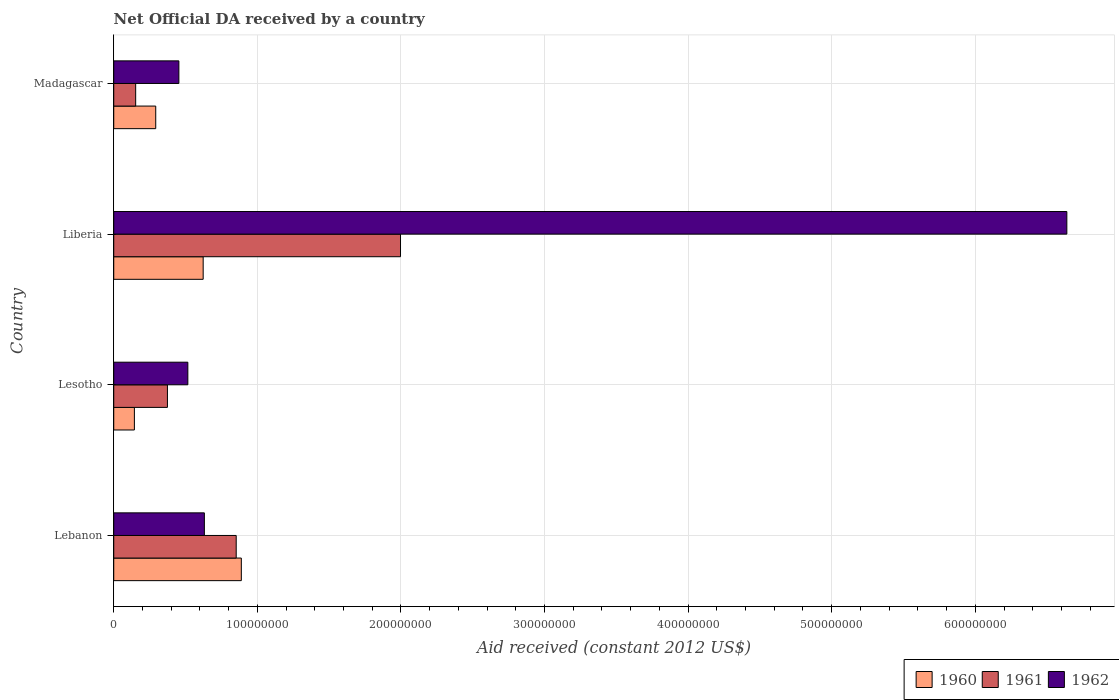How many different coloured bars are there?
Your answer should be very brief. 3. How many groups of bars are there?
Offer a terse response. 4. Are the number of bars per tick equal to the number of legend labels?
Your answer should be very brief. Yes. What is the label of the 3rd group of bars from the top?
Provide a short and direct response. Lesotho. What is the net official development assistance aid received in 1960 in Lesotho?
Your answer should be compact. 1.44e+07. Across all countries, what is the maximum net official development assistance aid received in 1962?
Make the answer very short. 6.64e+08. Across all countries, what is the minimum net official development assistance aid received in 1961?
Your answer should be compact. 1.53e+07. In which country was the net official development assistance aid received in 1960 maximum?
Your response must be concise. Lebanon. In which country was the net official development assistance aid received in 1960 minimum?
Keep it short and to the point. Lesotho. What is the total net official development assistance aid received in 1960 in the graph?
Make the answer very short. 1.95e+08. What is the difference between the net official development assistance aid received in 1960 in Lebanon and that in Lesotho?
Make the answer very short. 7.45e+07. What is the difference between the net official development assistance aid received in 1962 in Lesotho and the net official development assistance aid received in 1960 in Lebanon?
Provide a short and direct response. -3.72e+07. What is the average net official development assistance aid received in 1960 per country?
Your answer should be compact. 4.87e+07. What is the difference between the net official development assistance aid received in 1961 and net official development assistance aid received in 1960 in Lesotho?
Offer a terse response. 2.30e+07. In how many countries, is the net official development assistance aid received in 1962 greater than 460000000 US$?
Make the answer very short. 1. What is the ratio of the net official development assistance aid received in 1960 in Liberia to that in Madagascar?
Make the answer very short. 2.13. Is the difference between the net official development assistance aid received in 1961 in Lebanon and Lesotho greater than the difference between the net official development assistance aid received in 1960 in Lebanon and Lesotho?
Provide a succinct answer. No. What is the difference between the highest and the second highest net official development assistance aid received in 1960?
Offer a very short reply. 2.66e+07. What is the difference between the highest and the lowest net official development assistance aid received in 1960?
Your answer should be very brief. 7.45e+07. In how many countries, is the net official development assistance aid received in 1961 greater than the average net official development assistance aid received in 1961 taken over all countries?
Keep it short and to the point. 2. What does the 3rd bar from the bottom in Lesotho represents?
Keep it short and to the point. 1962. Is it the case that in every country, the sum of the net official development assistance aid received in 1962 and net official development assistance aid received in 1961 is greater than the net official development assistance aid received in 1960?
Your answer should be compact. Yes. Are all the bars in the graph horizontal?
Provide a succinct answer. Yes. How many countries are there in the graph?
Ensure brevity in your answer.  4. Are the values on the major ticks of X-axis written in scientific E-notation?
Your answer should be very brief. No. What is the title of the graph?
Your response must be concise. Net Official DA received by a country. What is the label or title of the X-axis?
Offer a terse response. Aid received (constant 2012 US$). What is the Aid received (constant 2012 US$) of 1960 in Lebanon?
Your answer should be compact. 8.88e+07. What is the Aid received (constant 2012 US$) of 1961 in Lebanon?
Your answer should be very brief. 8.53e+07. What is the Aid received (constant 2012 US$) in 1962 in Lebanon?
Ensure brevity in your answer.  6.31e+07. What is the Aid received (constant 2012 US$) in 1960 in Lesotho?
Your answer should be compact. 1.44e+07. What is the Aid received (constant 2012 US$) of 1961 in Lesotho?
Ensure brevity in your answer.  3.74e+07. What is the Aid received (constant 2012 US$) in 1962 in Lesotho?
Your answer should be very brief. 5.16e+07. What is the Aid received (constant 2012 US$) of 1960 in Liberia?
Your response must be concise. 6.23e+07. What is the Aid received (constant 2012 US$) of 1961 in Liberia?
Provide a short and direct response. 2.00e+08. What is the Aid received (constant 2012 US$) in 1962 in Liberia?
Make the answer very short. 6.64e+08. What is the Aid received (constant 2012 US$) of 1960 in Madagascar?
Your answer should be very brief. 2.92e+07. What is the Aid received (constant 2012 US$) of 1961 in Madagascar?
Ensure brevity in your answer.  1.53e+07. What is the Aid received (constant 2012 US$) of 1962 in Madagascar?
Make the answer very short. 4.54e+07. Across all countries, what is the maximum Aid received (constant 2012 US$) of 1960?
Provide a short and direct response. 8.88e+07. Across all countries, what is the maximum Aid received (constant 2012 US$) in 1961?
Offer a very short reply. 2.00e+08. Across all countries, what is the maximum Aid received (constant 2012 US$) of 1962?
Offer a very short reply. 6.64e+08. Across all countries, what is the minimum Aid received (constant 2012 US$) in 1960?
Provide a short and direct response. 1.44e+07. Across all countries, what is the minimum Aid received (constant 2012 US$) of 1961?
Provide a succinct answer. 1.53e+07. Across all countries, what is the minimum Aid received (constant 2012 US$) in 1962?
Your response must be concise. 4.54e+07. What is the total Aid received (constant 2012 US$) in 1960 in the graph?
Keep it short and to the point. 1.95e+08. What is the total Aid received (constant 2012 US$) in 1961 in the graph?
Keep it short and to the point. 3.38e+08. What is the total Aid received (constant 2012 US$) in 1962 in the graph?
Ensure brevity in your answer.  8.24e+08. What is the difference between the Aid received (constant 2012 US$) in 1960 in Lebanon and that in Lesotho?
Give a very brief answer. 7.45e+07. What is the difference between the Aid received (constant 2012 US$) of 1961 in Lebanon and that in Lesotho?
Your answer should be very brief. 4.79e+07. What is the difference between the Aid received (constant 2012 US$) in 1962 in Lebanon and that in Lesotho?
Make the answer very short. 1.15e+07. What is the difference between the Aid received (constant 2012 US$) in 1960 in Lebanon and that in Liberia?
Provide a succinct answer. 2.66e+07. What is the difference between the Aid received (constant 2012 US$) in 1961 in Lebanon and that in Liberia?
Your answer should be compact. -1.14e+08. What is the difference between the Aid received (constant 2012 US$) of 1962 in Lebanon and that in Liberia?
Offer a terse response. -6.01e+08. What is the difference between the Aid received (constant 2012 US$) in 1960 in Lebanon and that in Madagascar?
Offer a very short reply. 5.96e+07. What is the difference between the Aid received (constant 2012 US$) of 1961 in Lebanon and that in Madagascar?
Offer a very short reply. 7.00e+07. What is the difference between the Aid received (constant 2012 US$) in 1962 in Lebanon and that in Madagascar?
Keep it short and to the point. 1.78e+07. What is the difference between the Aid received (constant 2012 US$) in 1960 in Lesotho and that in Liberia?
Keep it short and to the point. -4.79e+07. What is the difference between the Aid received (constant 2012 US$) in 1961 in Lesotho and that in Liberia?
Provide a short and direct response. -1.62e+08. What is the difference between the Aid received (constant 2012 US$) in 1962 in Lesotho and that in Liberia?
Offer a terse response. -6.12e+08. What is the difference between the Aid received (constant 2012 US$) in 1960 in Lesotho and that in Madagascar?
Your answer should be compact. -1.49e+07. What is the difference between the Aid received (constant 2012 US$) of 1961 in Lesotho and that in Madagascar?
Offer a very short reply. 2.21e+07. What is the difference between the Aid received (constant 2012 US$) of 1962 in Lesotho and that in Madagascar?
Offer a terse response. 6.25e+06. What is the difference between the Aid received (constant 2012 US$) in 1960 in Liberia and that in Madagascar?
Provide a short and direct response. 3.30e+07. What is the difference between the Aid received (constant 2012 US$) of 1961 in Liberia and that in Madagascar?
Make the answer very short. 1.84e+08. What is the difference between the Aid received (constant 2012 US$) in 1962 in Liberia and that in Madagascar?
Offer a very short reply. 6.18e+08. What is the difference between the Aid received (constant 2012 US$) in 1960 in Lebanon and the Aid received (constant 2012 US$) in 1961 in Lesotho?
Provide a succinct answer. 5.15e+07. What is the difference between the Aid received (constant 2012 US$) of 1960 in Lebanon and the Aid received (constant 2012 US$) of 1962 in Lesotho?
Your answer should be very brief. 3.72e+07. What is the difference between the Aid received (constant 2012 US$) in 1961 in Lebanon and the Aid received (constant 2012 US$) in 1962 in Lesotho?
Give a very brief answer. 3.37e+07. What is the difference between the Aid received (constant 2012 US$) in 1960 in Lebanon and the Aid received (constant 2012 US$) in 1961 in Liberia?
Your answer should be very brief. -1.11e+08. What is the difference between the Aid received (constant 2012 US$) of 1960 in Lebanon and the Aid received (constant 2012 US$) of 1962 in Liberia?
Keep it short and to the point. -5.75e+08. What is the difference between the Aid received (constant 2012 US$) in 1961 in Lebanon and the Aid received (constant 2012 US$) in 1962 in Liberia?
Your answer should be compact. -5.78e+08. What is the difference between the Aid received (constant 2012 US$) of 1960 in Lebanon and the Aid received (constant 2012 US$) of 1961 in Madagascar?
Ensure brevity in your answer.  7.36e+07. What is the difference between the Aid received (constant 2012 US$) in 1960 in Lebanon and the Aid received (constant 2012 US$) in 1962 in Madagascar?
Keep it short and to the point. 4.35e+07. What is the difference between the Aid received (constant 2012 US$) in 1961 in Lebanon and the Aid received (constant 2012 US$) in 1962 in Madagascar?
Keep it short and to the point. 3.99e+07. What is the difference between the Aid received (constant 2012 US$) in 1960 in Lesotho and the Aid received (constant 2012 US$) in 1961 in Liberia?
Give a very brief answer. -1.85e+08. What is the difference between the Aid received (constant 2012 US$) in 1960 in Lesotho and the Aid received (constant 2012 US$) in 1962 in Liberia?
Your answer should be compact. -6.49e+08. What is the difference between the Aid received (constant 2012 US$) in 1961 in Lesotho and the Aid received (constant 2012 US$) in 1962 in Liberia?
Provide a succinct answer. -6.26e+08. What is the difference between the Aid received (constant 2012 US$) in 1960 in Lesotho and the Aid received (constant 2012 US$) in 1961 in Madagascar?
Keep it short and to the point. -8.90e+05. What is the difference between the Aid received (constant 2012 US$) of 1960 in Lesotho and the Aid received (constant 2012 US$) of 1962 in Madagascar?
Offer a very short reply. -3.10e+07. What is the difference between the Aid received (constant 2012 US$) of 1961 in Lesotho and the Aid received (constant 2012 US$) of 1962 in Madagascar?
Provide a succinct answer. -7.97e+06. What is the difference between the Aid received (constant 2012 US$) in 1960 in Liberia and the Aid received (constant 2012 US$) in 1961 in Madagascar?
Give a very brief answer. 4.70e+07. What is the difference between the Aid received (constant 2012 US$) of 1960 in Liberia and the Aid received (constant 2012 US$) of 1962 in Madagascar?
Your response must be concise. 1.69e+07. What is the difference between the Aid received (constant 2012 US$) of 1961 in Liberia and the Aid received (constant 2012 US$) of 1962 in Madagascar?
Your answer should be very brief. 1.54e+08. What is the average Aid received (constant 2012 US$) in 1960 per country?
Keep it short and to the point. 4.87e+07. What is the average Aid received (constant 2012 US$) in 1961 per country?
Your answer should be very brief. 8.44e+07. What is the average Aid received (constant 2012 US$) in 1962 per country?
Give a very brief answer. 2.06e+08. What is the difference between the Aid received (constant 2012 US$) in 1960 and Aid received (constant 2012 US$) in 1961 in Lebanon?
Keep it short and to the point. 3.57e+06. What is the difference between the Aid received (constant 2012 US$) of 1960 and Aid received (constant 2012 US$) of 1962 in Lebanon?
Your answer should be compact. 2.57e+07. What is the difference between the Aid received (constant 2012 US$) of 1961 and Aid received (constant 2012 US$) of 1962 in Lebanon?
Offer a very short reply. 2.22e+07. What is the difference between the Aid received (constant 2012 US$) in 1960 and Aid received (constant 2012 US$) in 1961 in Lesotho?
Keep it short and to the point. -2.30e+07. What is the difference between the Aid received (constant 2012 US$) of 1960 and Aid received (constant 2012 US$) of 1962 in Lesotho?
Offer a terse response. -3.72e+07. What is the difference between the Aid received (constant 2012 US$) of 1961 and Aid received (constant 2012 US$) of 1962 in Lesotho?
Your answer should be very brief. -1.42e+07. What is the difference between the Aid received (constant 2012 US$) of 1960 and Aid received (constant 2012 US$) of 1961 in Liberia?
Your answer should be very brief. -1.37e+08. What is the difference between the Aid received (constant 2012 US$) of 1960 and Aid received (constant 2012 US$) of 1962 in Liberia?
Keep it short and to the point. -6.01e+08. What is the difference between the Aid received (constant 2012 US$) of 1961 and Aid received (constant 2012 US$) of 1962 in Liberia?
Your response must be concise. -4.64e+08. What is the difference between the Aid received (constant 2012 US$) of 1960 and Aid received (constant 2012 US$) of 1961 in Madagascar?
Offer a very short reply. 1.40e+07. What is the difference between the Aid received (constant 2012 US$) of 1960 and Aid received (constant 2012 US$) of 1962 in Madagascar?
Provide a succinct answer. -1.61e+07. What is the difference between the Aid received (constant 2012 US$) of 1961 and Aid received (constant 2012 US$) of 1962 in Madagascar?
Ensure brevity in your answer.  -3.01e+07. What is the ratio of the Aid received (constant 2012 US$) of 1960 in Lebanon to that in Lesotho?
Your answer should be very brief. 6.18. What is the ratio of the Aid received (constant 2012 US$) of 1961 in Lebanon to that in Lesotho?
Your answer should be compact. 2.28. What is the ratio of the Aid received (constant 2012 US$) in 1962 in Lebanon to that in Lesotho?
Offer a terse response. 1.22. What is the ratio of the Aid received (constant 2012 US$) in 1960 in Lebanon to that in Liberia?
Offer a very short reply. 1.43. What is the ratio of the Aid received (constant 2012 US$) of 1961 in Lebanon to that in Liberia?
Make the answer very short. 0.43. What is the ratio of the Aid received (constant 2012 US$) in 1962 in Lebanon to that in Liberia?
Offer a very short reply. 0.1. What is the ratio of the Aid received (constant 2012 US$) of 1960 in Lebanon to that in Madagascar?
Your answer should be very brief. 3.04. What is the ratio of the Aid received (constant 2012 US$) of 1961 in Lebanon to that in Madagascar?
Your answer should be compact. 5.58. What is the ratio of the Aid received (constant 2012 US$) of 1962 in Lebanon to that in Madagascar?
Your answer should be compact. 1.39. What is the ratio of the Aid received (constant 2012 US$) of 1960 in Lesotho to that in Liberia?
Ensure brevity in your answer.  0.23. What is the ratio of the Aid received (constant 2012 US$) in 1961 in Lesotho to that in Liberia?
Give a very brief answer. 0.19. What is the ratio of the Aid received (constant 2012 US$) in 1962 in Lesotho to that in Liberia?
Keep it short and to the point. 0.08. What is the ratio of the Aid received (constant 2012 US$) in 1960 in Lesotho to that in Madagascar?
Make the answer very short. 0.49. What is the ratio of the Aid received (constant 2012 US$) of 1961 in Lesotho to that in Madagascar?
Give a very brief answer. 2.45. What is the ratio of the Aid received (constant 2012 US$) in 1962 in Lesotho to that in Madagascar?
Make the answer very short. 1.14. What is the ratio of the Aid received (constant 2012 US$) of 1960 in Liberia to that in Madagascar?
Your response must be concise. 2.13. What is the ratio of the Aid received (constant 2012 US$) of 1961 in Liberia to that in Madagascar?
Provide a short and direct response. 13.08. What is the ratio of the Aid received (constant 2012 US$) of 1962 in Liberia to that in Madagascar?
Give a very brief answer. 14.63. What is the difference between the highest and the second highest Aid received (constant 2012 US$) in 1960?
Your response must be concise. 2.66e+07. What is the difference between the highest and the second highest Aid received (constant 2012 US$) of 1961?
Make the answer very short. 1.14e+08. What is the difference between the highest and the second highest Aid received (constant 2012 US$) of 1962?
Provide a short and direct response. 6.01e+08. What is the difference between the highest and the lowest Aid received (constant 2012 US$) in 1960?
Your answer should be compact. 7.45e+07. What is the difference between the highest and the lowest Aid received (constant 2012 US$) of 1961?
Make the answer very short. 1.84e+08. What is the difference between the highest and the lowest Aid received (constant 2012 US$) in 1962?
Ensure brevity in your answer.  6.18e+08. 